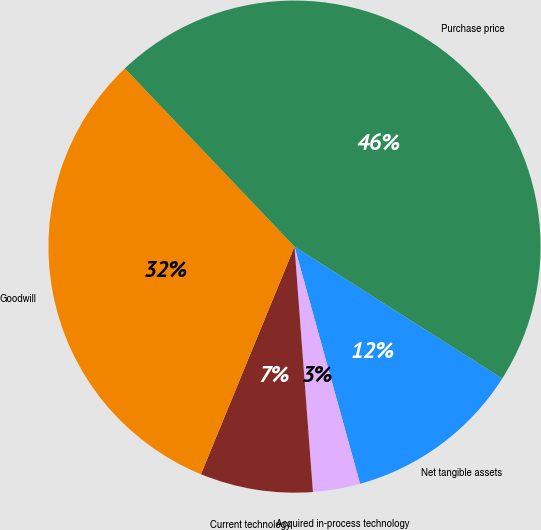Convert chart. <chart><loc_0><loc_0><loc_500><loc_500><pie_chart><fcel>Net tangible assets<fcel>Acquired in-process technology<fcel>Current technology<fcel>Goodwill<fcel>Purchase price<nl><fcel>11.7%<fcel>3.1%<fcel>7.4%<fcel>31.68%<fcel>46.11%<nl></chart> 